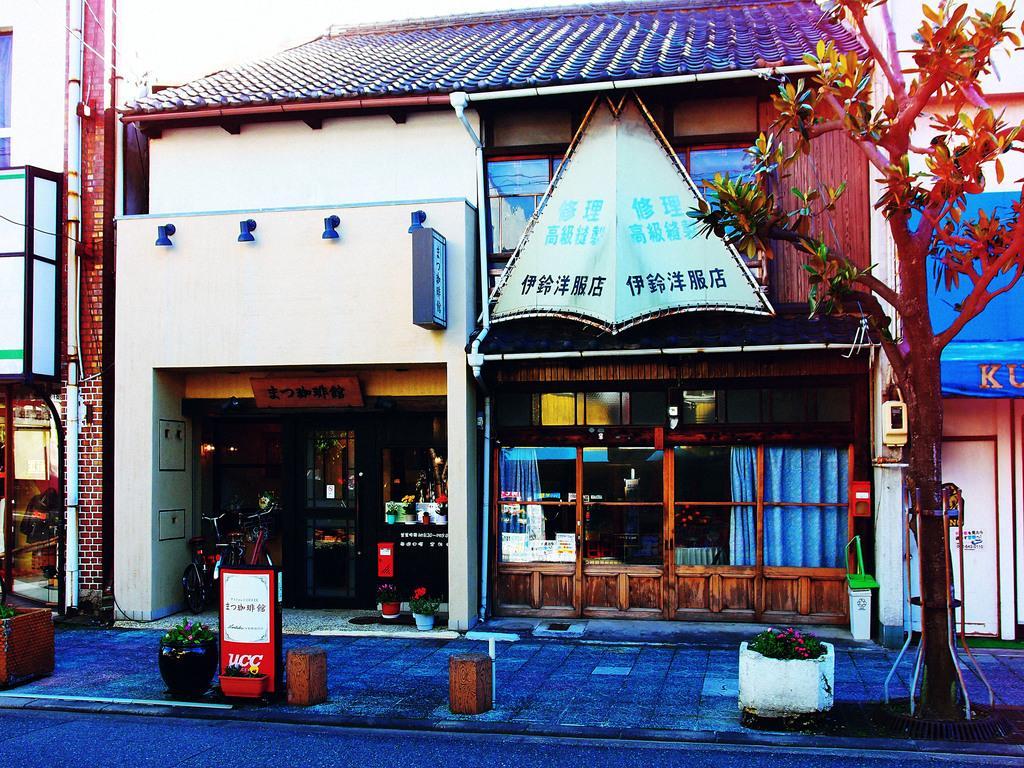In one or two sentences, can you explain what this image depicts? At the bottom of the image there are some plants and trees and poles. In the middle of the image there are some buildings, in the building there are some bicycles. 